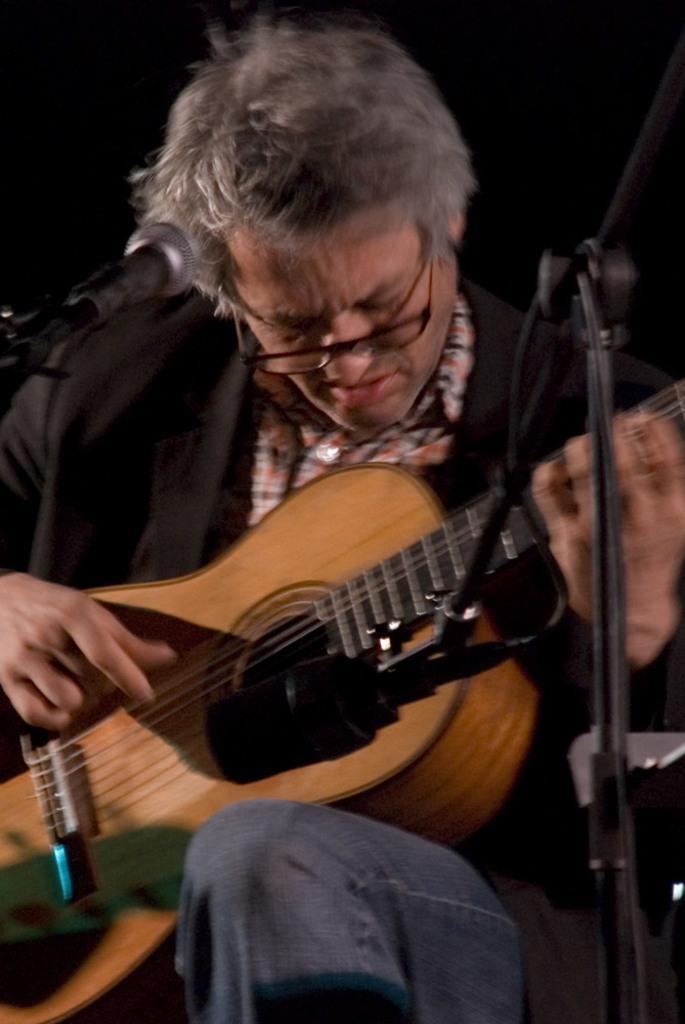Describe this image in one or two sentences. In this picture, we see man in black jacket and blue jeans is wearing spectacles. He is holding guitar in his hands and he is playing it. In front of him, we see a microphone. 